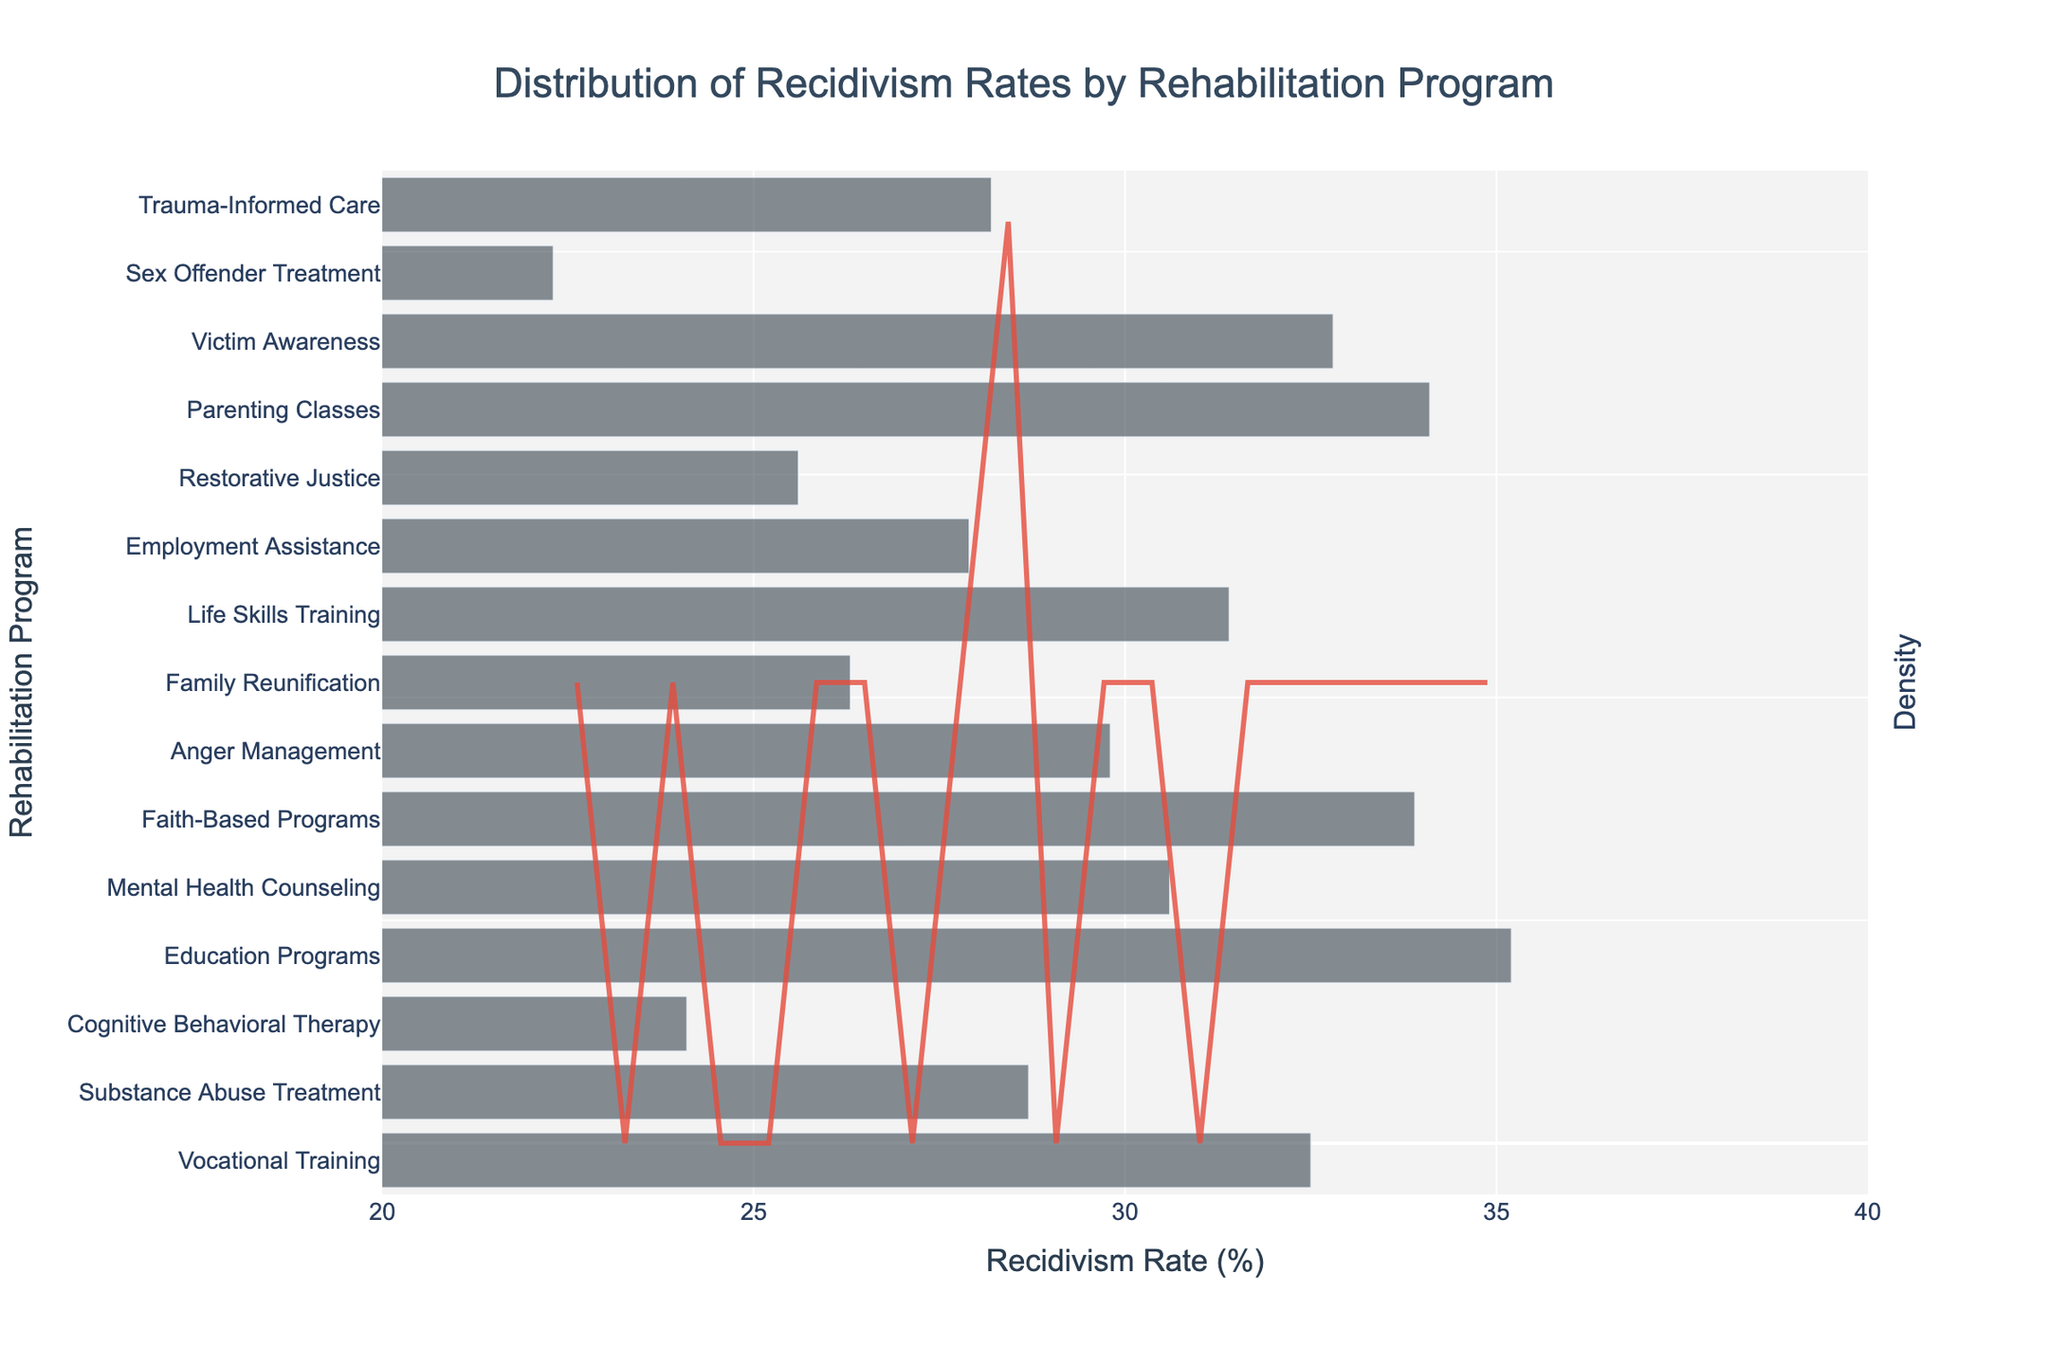What is the title of the figure? The title is typically placed at the top of the figure. Here, it reads "Distribution of Recidivism Rates by Rehabilitation Program".
Answer: Distribution of Recidivism Rates by Rehabilitation Program What value is indicated by the peak of the density curve? The peak of the density curve represents the highest density of recidivism rates, located around the highest y-value in the KDE line.
Answer: Around 28% Which rehabilitation program shows the highest recidivism rate? By looking at the horizontal bars and their corresponding values, the "Education Programs" bar extends furthest along the x-axis, indicating the highest recidivism rate.
Answer: Education Programs Which program has the lowest recidivism rate? By observing the shortest bar on the x-axis, it is the "Sex Offender Treatment" program.
Answer: Sex Offender Treatment How many programs have a recidivism rate higher than 30%? Count the number of horizontal bars with recidivism rates extending beyond 30% on the x-axis.
Answer: 7 What is the average recidivism rate across all programs? Sum all recidivism rates and divide by the number of programs: (32.5 + 28.7 + 24.1 + 35.2 + 30.6 + 33.9 + 29.8 + 26.3 + 31.4 + 27.9 + 25.6 + 34.1 + 32.8 + 22.3 + 28.2) / 15 = 445.4 / 15.
Answer: 29.7 Which programs have a recidivism rate that falls between the two peaks of the density curve? Identify the range of values between the two peaks of the density curve, then check which program bars fall within that range. Peaks appear around ~25% and ~32%, so this includes "Family Reunification", "Employment Assistance", "Trauma-Informed Care", "Anger Management", and "Substance Abuse Treatment".
Answer: Family Reunification, Employment Assistance, Trauma-Informed Care, Anger Management, Substance Abuse Treatment Which rehabilitation programs have a recidivism rate below the mean provided by the density curve? The peak of the density curve is around 28%, which can be inferred as the mean. Identify programs with bars less than 28% on the x-axis.
Answer: Cognitive Behavioral Therapy, Restorative Justice, Sex Offender Treatment 